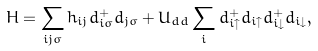Convert formula to latex. <formula><loc_0><loc_0><loc_500><loc_500>H = \sum _ { i j \sigma } h _ { i j } d ^ { + } _ { i \sigma } d _ { j \sigma } + U _ { d d } \sum _ { i } d ^ { + } _ { i \uparrow } d _ { i \uparrow } d ^ { + } _ { i \downarrow } d _ { i \downarrow } ,</formula> 